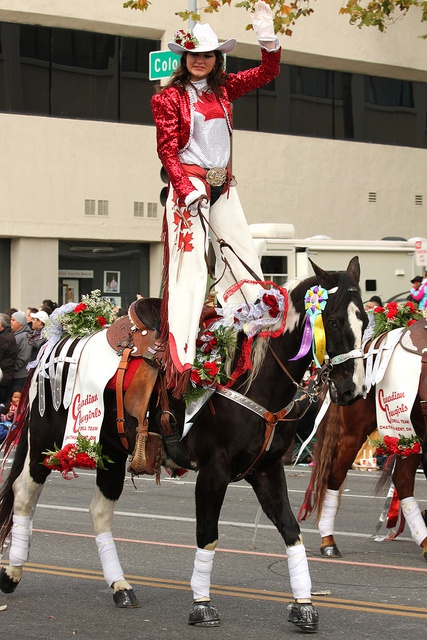Describe the objects in this image and their specific colors. I can see horse in beige, black, white, darkgray, and gray tones, people in beige, ivory, maroon, black, and brown tones, horse in beige, white, black, maroon, and gray tones, truck in beige, tan, ivory, darkgray, and black tones, and people in beige, black, and gray tones in this image. 